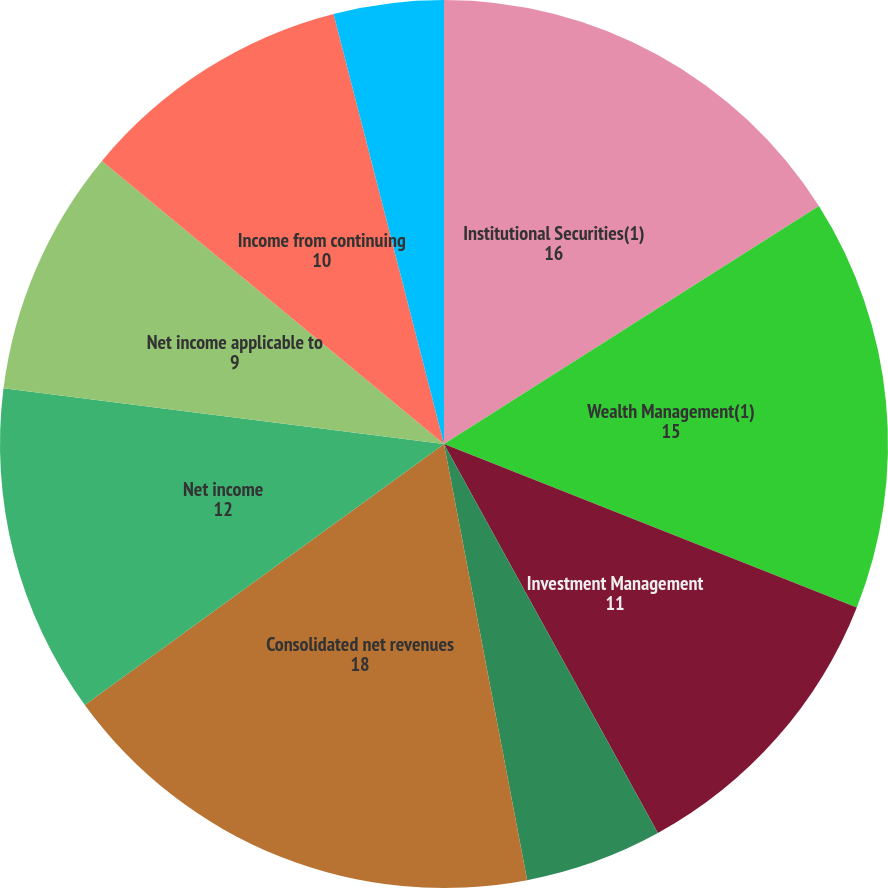<chart> <loc_0><loc_0><loc_500><loc_500><pie_chart><fcel>Institutional Securities(1)<fcel>Wealth Management(1)<fcel>Investment Management<fcel>Intersegment Eliminations<fcel>Consolidated net revenues<fcel>Net income<fcel>Net income applicable to<fcel>Income from continuing<fcel>Net gain (loss) from<nl><fcel>16.0%<fcel>15.0%<fcel>11.0%<fcel>5.0%<fcel>18.0%<fcel>12.0%<fcel>9.0%<fcel>10.0%<fcel>4.0%<nl></chart> 